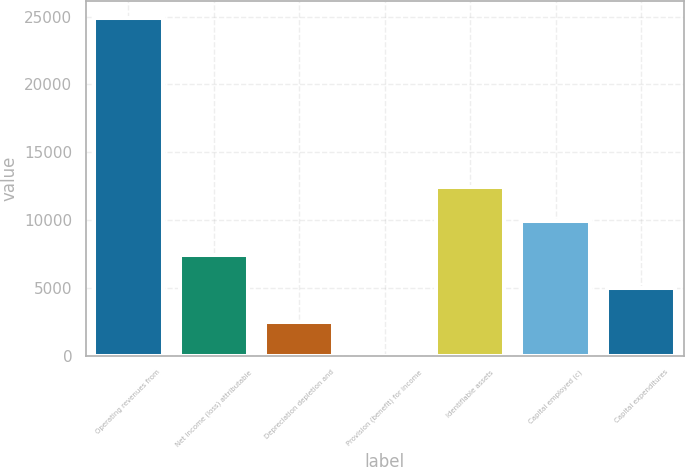Convert chart. <chart><loc_0><loc_0><loc_500><loc_500><bar_chart><fcel>Operating revenues from<fcel>Net income (loss) attributable<fcel>Depreciation depletion and<fcel>Provision (benefit) for income<fcel>Identifiable assets<fcel>Capital employed (c)<fcel>Capital expenditures<nl><fcel>24885<fcel>7468.3<fcel>2492.1<fcel>4<fcel>12444.5<fcel>9956.4<fcel>4980.2<nl></chart> 